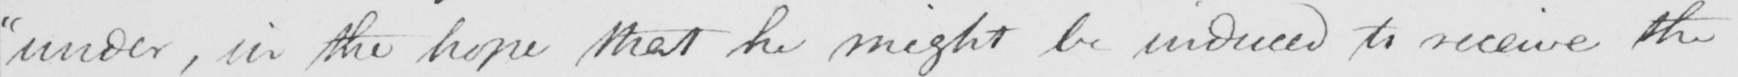Can you read and transcribe this handwriting? " under , in the hope that he might be induced to receive the 